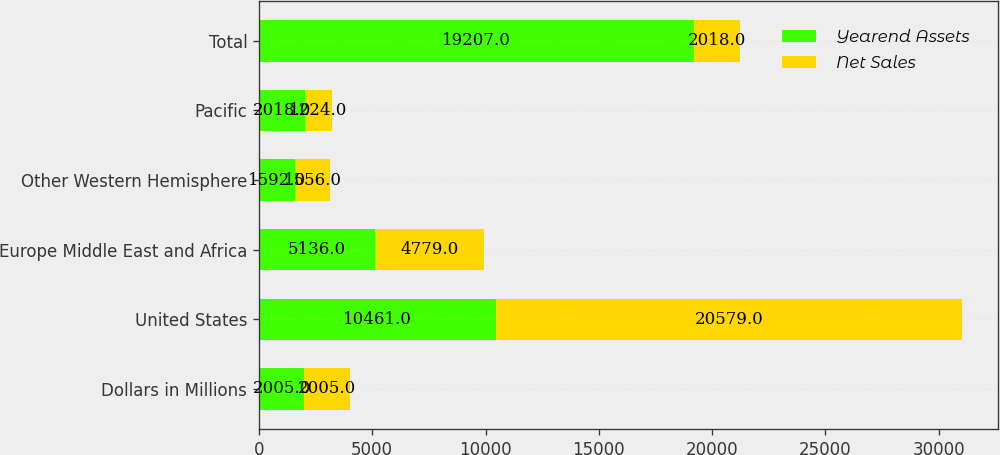Convert chart to OTSL. <chart><loc_0><loc_0><loc_500><loc_500><stacked_bar_chart><ecel><fcel>Dollars in Millions<fcel>United States<fcel>Europe Middle East and Africa<fcel>Other Western Hemisphere<fcel>Pacific<fcel>Total<nl><fcel>Yearend Assets<fcel>2005<fcel>10461<fcel>5136<fcel>1592<fcel>2018<fcel>19207<nl><fcel>Net Sales<fcel>2005<fcel>20579<fcel>4779<fcel>1556<fcel>1224<fcel>2018<nl></chart> 